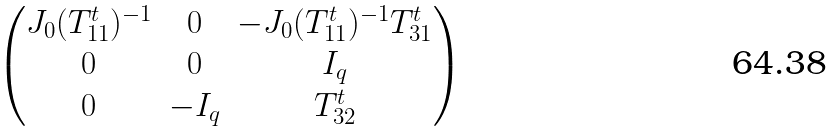<formula> <loc_0><loc_0><loc_500><loc_500>\begin{pmatrix} J _ { 0 } ( T ^ { t } _ { 1 1 } ) ^ { - 1 } & 0 & - J _ { 0 } ( T ^ { t } _ { 1 1 } ) ^ { - 1 } T ^ { t } _ { 3 1 } \\ 0 & 0 & I _ { q } \\ 0 & - I _ { q } & T ^ { t } _ { 3 2 } \end{pmatrix}</formula> 